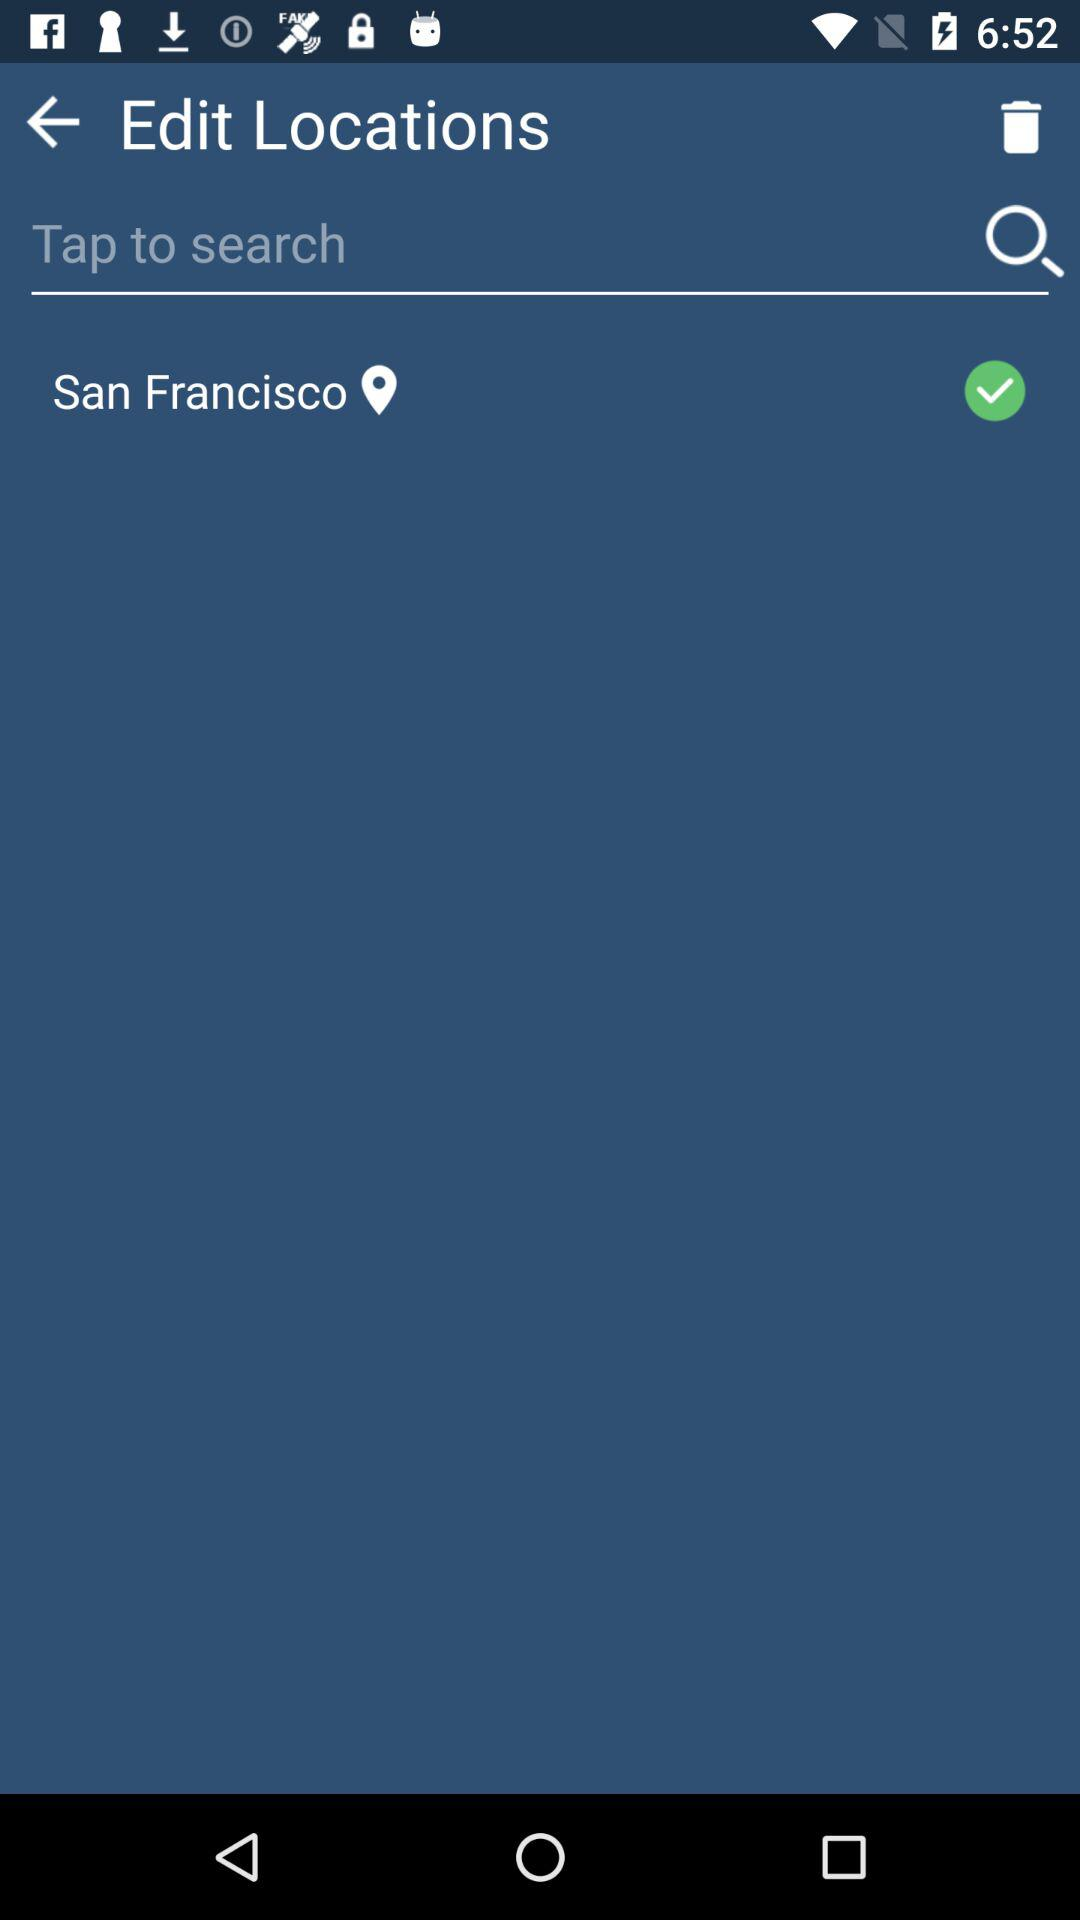What location is selected? The selected location is San Francisco. 